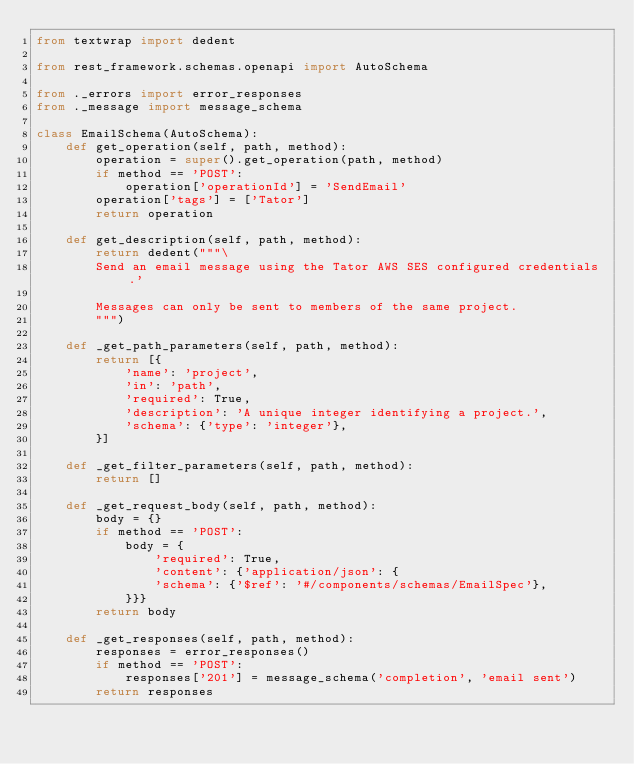Convert code to text. <code><loc_0><loc_0><loc_500><loc_500><_Python_>from textwrap import dedent

from rest_framework.schemas.openapi import AutoSchema

from ._errors import error_responses
from ._message import message_schema

class EmailSchema(AutoSchema):
    def get_operation(self, path, method):
        operation = super().get_operation(path, method)
        if method == 'POST':
            operation['operationId'] = 'SendEmail'
        operation['tags'] = ['Tator']
        return operation

    def get_description(self, path, method):
        return dedent("""\
        Send an email message using the Tator AWS SES configured credentials.'

        Messages can only be sent to members of the same project.
        """)

    def _get_path_parameters(self, path, method):
        return [{
            'name': 'project',
            'in': 'path',
            'required': True,
            'description': 'A unique integer identifying a project.',
            'schema': {'type': 'integer'},
        }]

    def _get_filter_parameters(self, path, method):
        return []

    def _get_request_body(self, path, method):
        body = {}
        if method == 'POST':
            body = {
                'required': True,
                'content': {'application/json': {
                'schema': {'$ref': '#/components/schemas/EmailSpec'},
            }}}
        return body

    def _get_responses(self, path, method):
        responses = error_responses()
        if method == 'POST':
            responses['201'] = message_schema('completion', 'email sent')
        return responses

</code> 